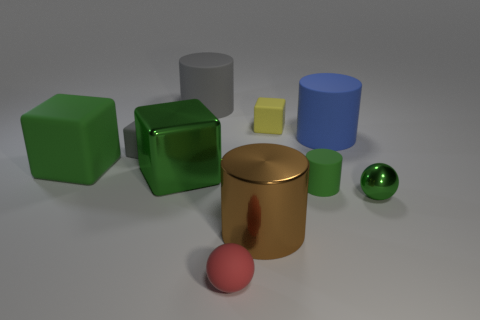There is a metallic object that is the same color as the big metal block; what is its shape?
Provide a succinct answer. Sphere. The large shiny block has what color?
Your answer should be very brief. Green. There is a large object that is behind the big rubber thing that is right of the small green rubber cylinder in front of the blue cylinder; what shape is it?
Keep it short and to the point. Cylinder. There is a green thing that is right of the green rubber block and on the left side of the red matte ball; what is its material?
Provide a succinct answer. Metal. There is a big rubber object that is behind the small object that is behind the blue matte cylinder; what shape is it?
Offer a terse response. Cylinder. Is there anything else that is the same color as the tiny metallic thing?
Ensure brevity in your answer.  Yes. Do the red rubber sphere and the green cube in front of the large rubber cube have the same size?
Keep it short and to the point. No. What number of large things are green cylinders or green metal cubes?
Your answer should be very brief. 1. Are there more blue matte objects than red cylinders?
Ensure brevity in your answer.  Yes. What number of tiny rubber things are to the right of the small sphere that is behind the small ball on the left side of the green matte cylinder?
Your answer should be compact. 0. 